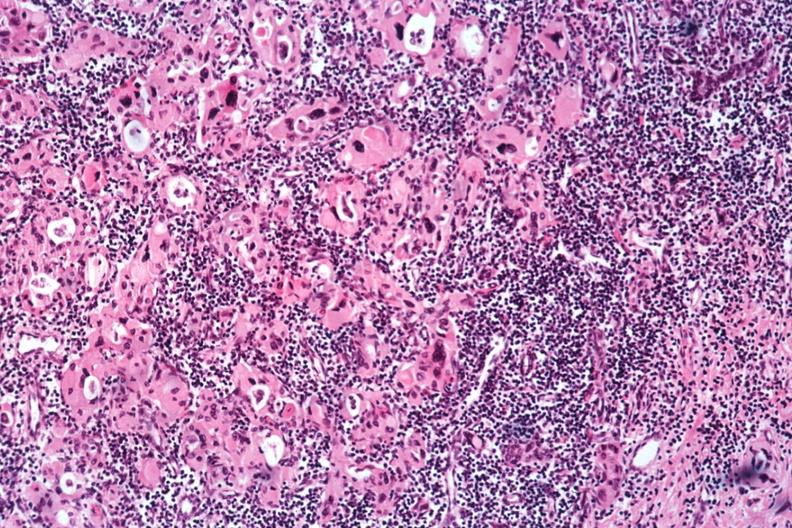what is present?
Answer the question using a single word or phrase. Endocrine 